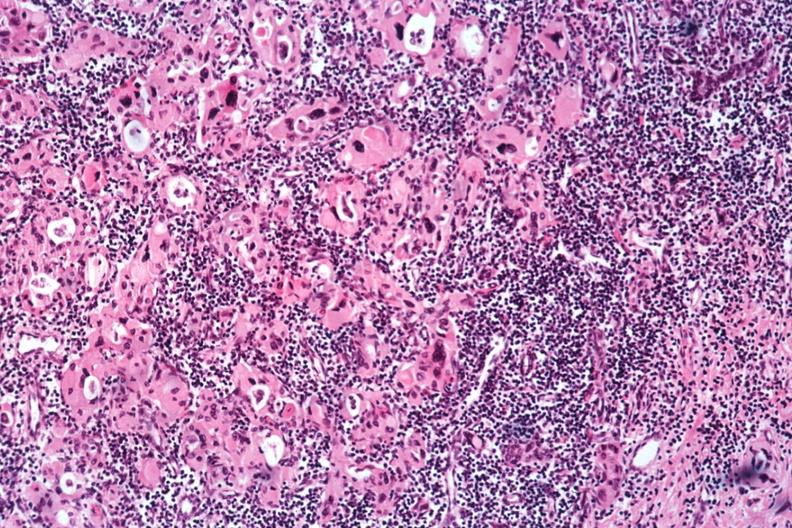what is present?
Answer the question using a single word or phrase. Endocrine 